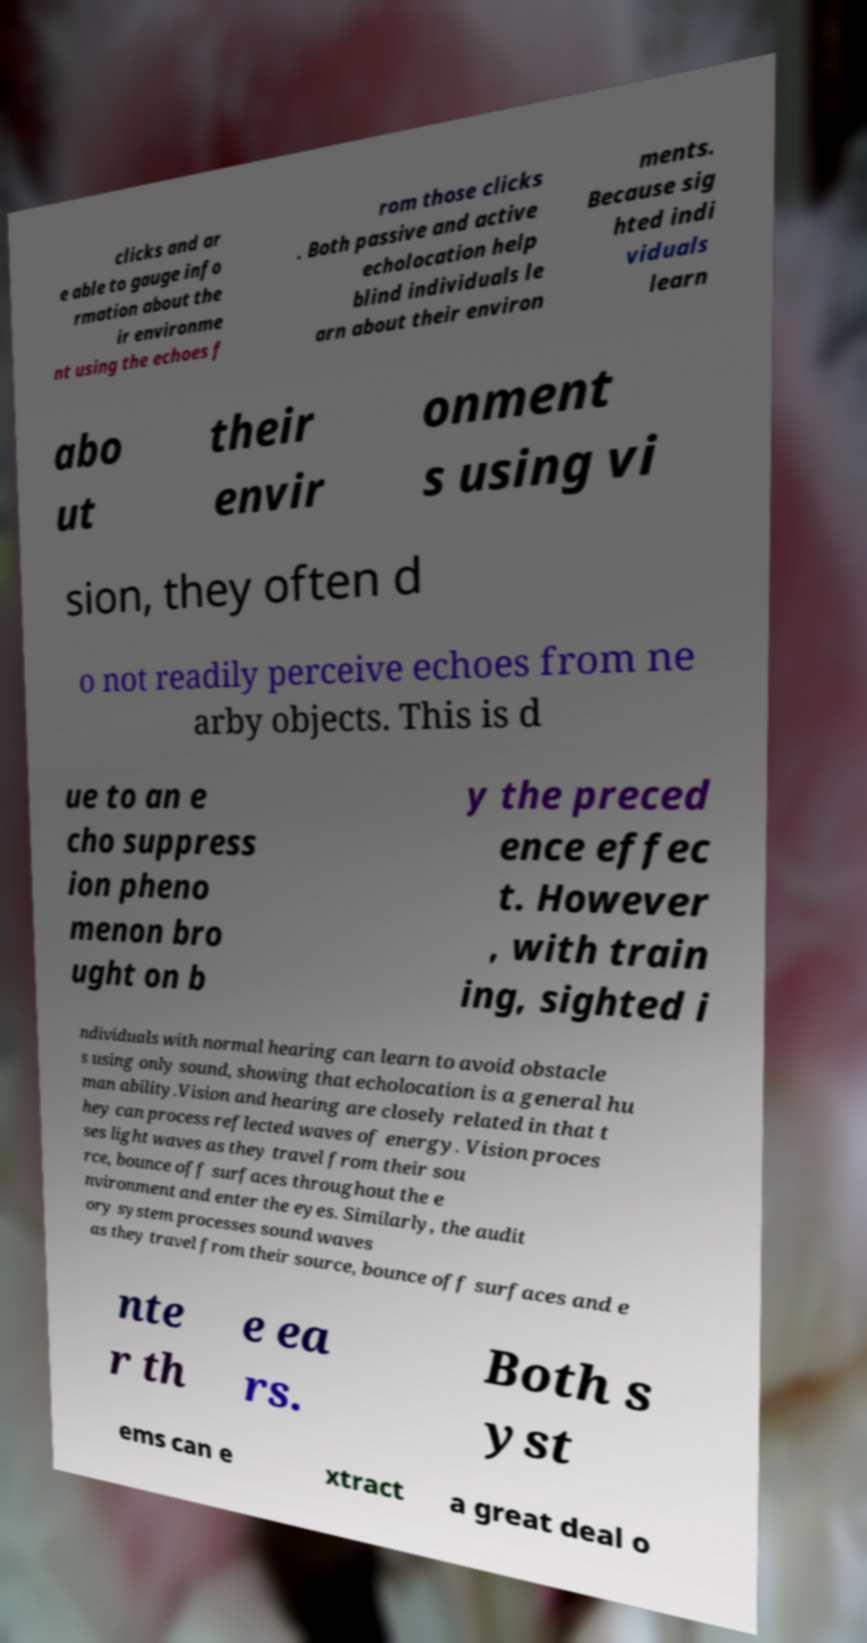What messages or text are displayed in this image? I need them in a readable, typed format. clicks and ar e able to gauge info rmation about the ir environme nt using the echoes f rom those clicks . Both passive and active echolocation help blind individuals le arn about their environ ments. Because sig hted indi viduals learn abo ut their envir onment s using vi sion, they often d o not readily perceive echoes from ne arby objects. This is d ue to an e cho suppress ion pheno menon bro ught on b y the preced ence effec t. However , with train ing, sighted i ndividuals with normal hearing can learn to avoid obstacle s using only sound, showing that echolocation is a general hu man ability.Vision and hearing are closely related in that t hey can process reflected waves of energy. Vision proces ses light waves as they travel from their sou rce, bounce off surfaces throughout the e nvironment and enter the eyes. Similarly, the audit ory system processes sound waves as they travel from their source, bounce off surfaces and e nte r th e ea rs. Both s yst ems can e xtract a great deal o 